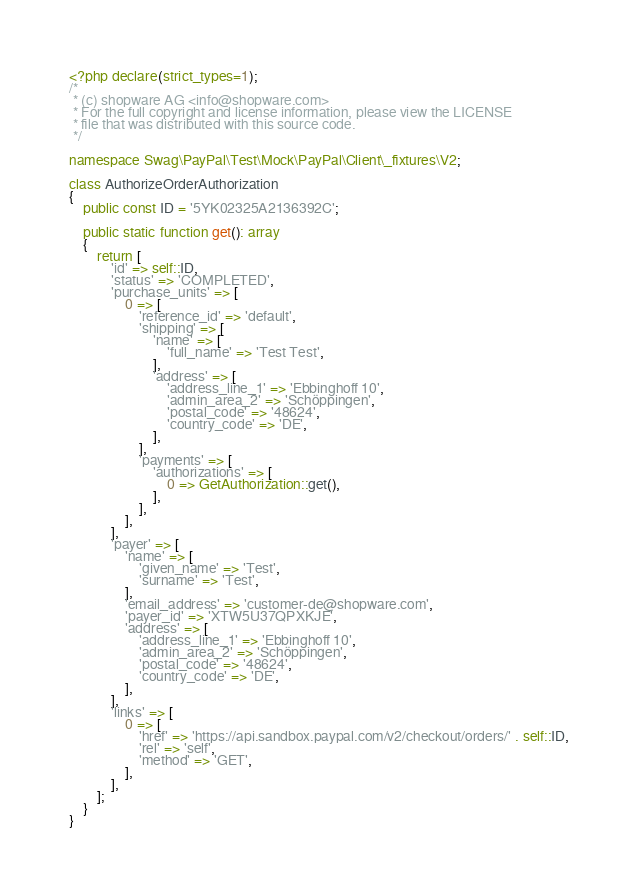<code> <loc_0><loc_0><loc_500><loc_500><_PHP_><?php declare(strict_types=1);
/*
 * (c) shopware AG <info@shopware.com>
 * For the full copyright and license information, please view the LICENSE
 * file that was distributed with this source code.
 */

namespace Swag\PayPal\Test\Mock\PayPal\Client\_fixtures\V2;

class AuthorizeOrderAuthorization
{
    public const ID = '5YK02325A2136392C';

    public static function get(): array
    {
        return [
            'id' => self::ID,
            'status' => 'COMPLETED',
            'purchase_units' => [
                0 => [
                    'reference_id' => 'default',
                    'shipping' => [
                        'name' => [
                            'full_name' => 'Test Test',
                        ],
                        'address' => [
                            'address_line_1' => 'Ebbinghoff 10',
                            'admin_area_2' => 'Schöppingen',
                            'postal_code' => '48624',
                            'country_code' => 'DE',
                        ],
                    ],
                    'payments' => [
                        'authorizations' => [
                            0 => GetAuthorization::get(),
                        ],
                    ],
                ],
            ],
            'payer' => [
                'name' => [
                    'given_name' => 'Test',
                    'surname' => 'Test',
                ],
                'email_address' => 'customer-de@shopware.com',
                'payer_id' => 'XTW5U37QPXKJE',
                'address' => [
                    'address_line_1' => 'Ebbinghoff 10',
                    'admin_area_2' => 'Schöppingen',
                    'postal_code' => '48624',
                    'country_code' => 'DE',
                ],
            ],
            'links' => [
                0 => [
                    'href' => 'https://api.sandbox.paypal.com/v2/checkout/orders/' . self::ID,
                    'rel' => 'self',
                    'method' => 'GET',
                ],
            ],
        ];
    }
}
</code> 